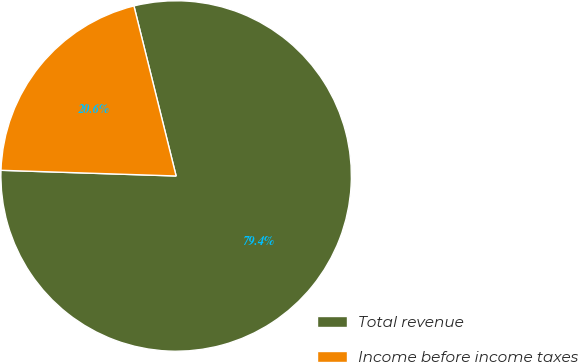Convert chart. <chart><loc_0><loc_0><loc_500><loc_500><pie_chart><fcel>Total revenue<fcel>Income before income taxes<nl><fcel>79.39%<fcel>20.61%<nl></chart> 